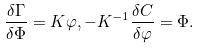Convert formula to latex. <formula><loc_0><loc_0><loc_500><loc_500>\frac { \delta \Gamma } { \delta \Phi } = K \varphi , - K ^ { - 1 } \frac { \delta C } { \delta \varphi } = \Phi .</formula> 